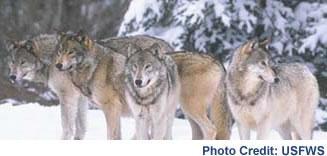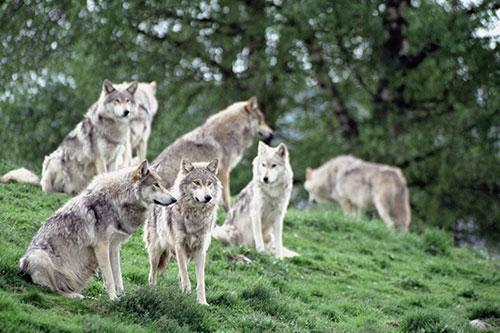The first image is the image on the left, the second image is the image on the right. For the images displayed, is the sentence "An image shows a horizontal row of exactly three wolves, and all are in similar poses." factually correct? Answer yes or no. No. The first image is the image on the left, the second image is the image on the right. Analyze the images presented: Is the assertion "The left image contains exactly three wolves." valid? Answer yes or no. No. 